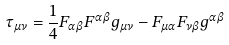<formula> <loc_0><loc_0><loc_500><loc_500>\tau _ { \mu \nu } = \frac { 1 } { 4 } F _ { \alpha \beta } F ^ { \alpha \beta } g _ { \mu \nu } - F _ { \mu \alpha } F _ { \nu \beta } g ^ { \alpha \beta }</formula> 